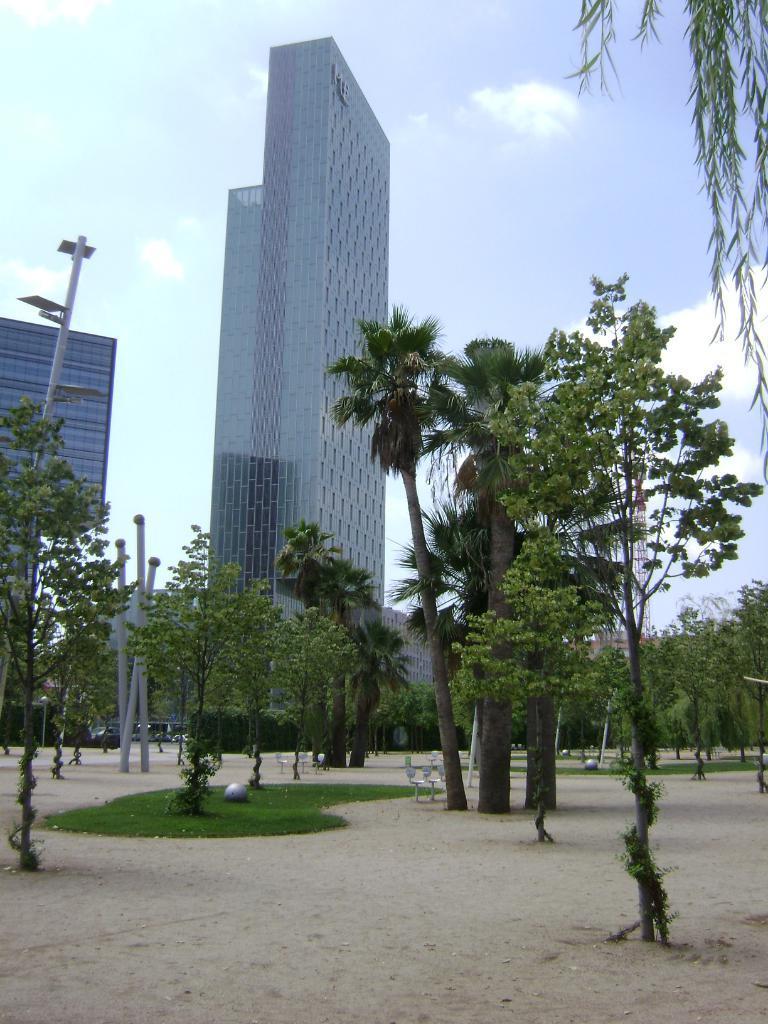Can you describe this image briefly? In this image, we can see few buildings, poles, trees, plants, grass. At the bottom, there is a ground. Here we can see some objects. Background there is a sky. 